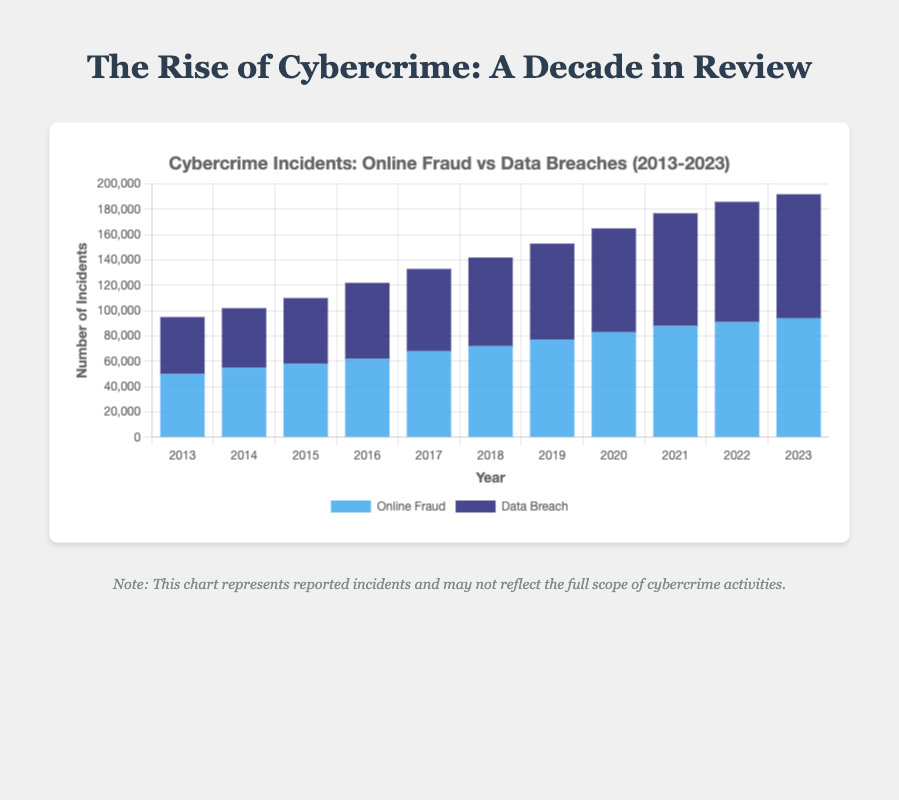How has the total number of cybercrime incidents changed from 2013 to 2023? To determine the change in total cybercrime incidents, we add the incidents of online fraud and data breaches for both 2013 and 2023. For 2013, the total is 50,000 (online fraud) + 45,000 (data breaches) = 95,000. For 2023, the total is 94,000 (online fraud) + 98,000 (data breaches) = 192,000. The change is 192,000 - 95,000 = 97,000.
Answer: Increased by 97,000 Which year had the highest number of data breaches reported? By examining the height of the dark blue bars, we see that 2023 reported the highest number of data breaches at 98,000.
Answer: 2023 What is the average number of online fraud incidents reported annually over the decade? To find the average, sum the online fraud incidents for each year and then divide by the number of years (11 years). The total is 50,000 + 55,000 + 58,000 + 62,000 + 68,000 + 72,000 + 77,000 + 83,000 + 88,000 + 91,000 + 94,000 = 798,000. The average is 798,000 / 11 = 72,545.45.
Answer: 72,545 Which year saw a higher increase in online fraud incidents compared to the previous year? Compare the year-on-year increases for online fraud. The largest jump appears between 2019 and 2020: from 77,000 to 83,000, an increase of 83,000 - 77,000 = 6,000.
Answer: 2020 In which year did the total number of incidents (online fraud + data breaches) first exceed 150,000? By summing the incidents for each subsequent year and comparing to 150,000, we find that in 2020 the total was 83,000 (online fraud) + 82,000 (data breaches) = 165,000.
Answer: 2020 How do the incidents of online fraud and data breaches compare in 2023? In 2023, online fraud incidents are 94,000 and data breaches are 98,000, indicating that data breaches exceed online fraud by 98,000 - 94,000 = 4,000.
Answer: Data breaches exceed online fraud by 4,000 What is the overall trend for data breaches from 2013 to 2023? Observing the height of the dark blue bars, data breaches have generally increased each year from 45,000 in 2013 to 98,000 in 2023. This indicates a steady upward trend.
Answer: Increasing trend How many more online fraud incidents were recorded in 2017 compared to 2014? Calculate the difference between the number of online fraud incidents in the two years: 68,000 (2017) - 55,000 (2014) = 13,000.
Answer: 13,000 more Which type of cybercrime grew at a faster rate from 2013 to 2023? Data breaches grew from 45,000 to 98,000, an increase of 98,000 - 45,000 = 53,000. Online fraud grew from 50,000 to 94,000, an increase of 94,000 - 50,000 = 44,000. Data breaches grew faster.
Answer: Data breaches grew faster 